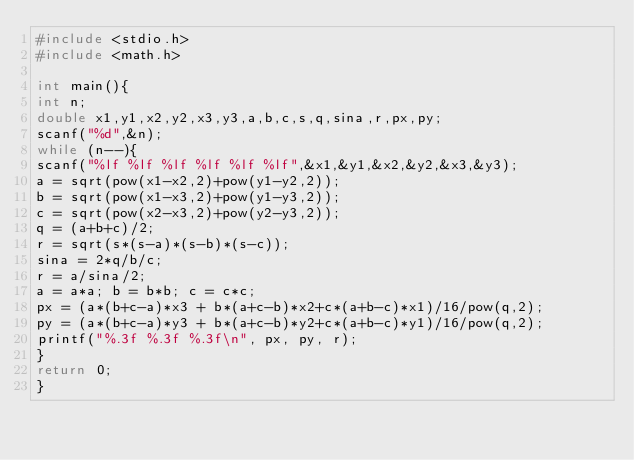<code> <loc_0><loc_0><loc_500><loc_500><_C_>#include <stdio.h>
#include <math.h>
 
int main(){
int n;
double x1,y1,x2,y2,x3,y3,a,b,c,s,q,sina,r,px,py;
scanf("%d",&n);
while (n--){
scanf("%lf %lf %lf %lf %lf %lf",&x1,&y1,&x2,&y2,&x3,&y3);
a = sqrt(pow(x1-x2,2)+pow(y1-y2,2));
b = sqrt(pow(x1-x3,2)+pow(y1-y3,2));
c = sqrt(pow(x2-x3,2)+pow(y2-y3,2));
q = (a+b+c)/2;
r = sqrt(s*(s-a)*(s-b)*(s-c));
sina = 2*q/b/c;
r = a/sina/2;
a = a*a; b = b*b; c = c*c;
px = (a*(b+c-a)*x3 + b*(a+c-b)*x2+c*(a+b-c)*x1)/16/pow(q,2);
py = (a*(b+c-a)*y3 + b*(a+c-b)*y2+c*(a+b-c)*y1)/16/pow(q,2);
printf("%.3f %.3f %.3f\n", px, py, r);
}
return 0;
}</code> 